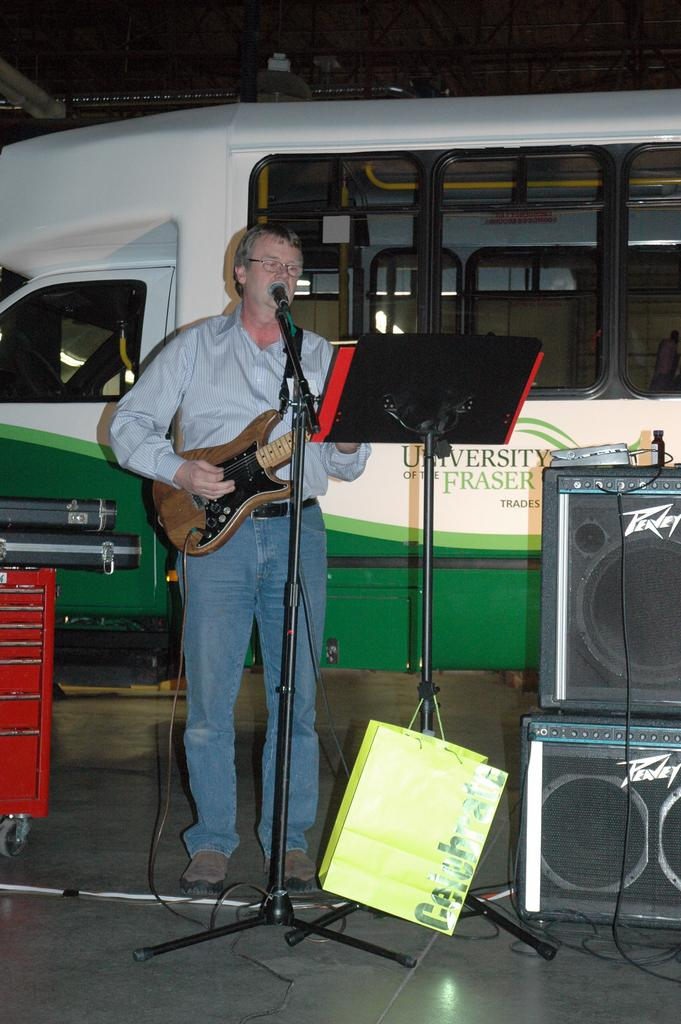What is the main subject of the image? The main subject of the image is a bus. What other objects or items can be seen in the image? There is a microphone (mike) and a man holding a guitar in the image. Where are the sound boxes located in the image? The sound boxes are on the right side of the image. What type of show is the man performing in the image? There is no indication of a show or performance in the image; it simply shows a man holding a guitar and a bus with a microphone and sound boxes. 